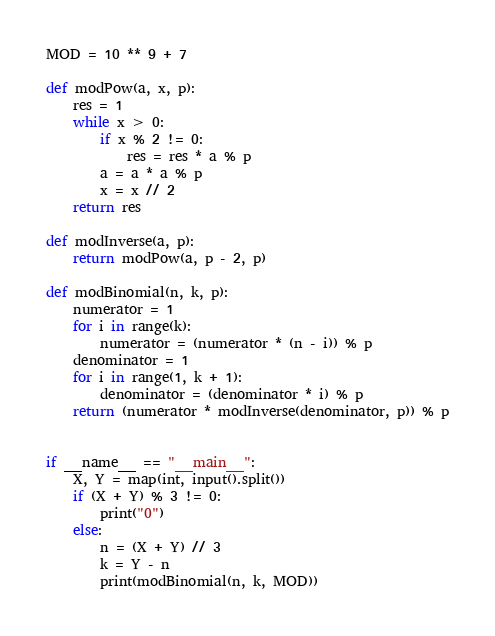<code> <loc_0><loc_0><loc_500><loc_500><_Python_>MOD = 10 ** 9 + 7

def modPow(a, x, p):
	res = 1
	while x > 0:
		if x % 2 != 0:
			res = res * a % p
		a = a * a % p
		x = x // 2
	return res
 
def modInverse(a, p):
	return modPow(a, p - 2, p)
 
def modBinomial(n, k, p):
	numerator = 1
	for i in range(k):
		numerator = (numerator * (n - i)) % p
	denominator = 1
	for i in range(1, k + 1):
		denominator = (denominator * i) % p
	return (numerator * modInverse(denominator, p)) % p


if __name__ == "__main__":
	X, Y = map(int, input().split())
	if (X + Y) % 3 != 0:
		print("0")
	else:
		n = (X + Y) // 3
		k = Y - n
		print(modBinomial(n, k, MOD))</code> 